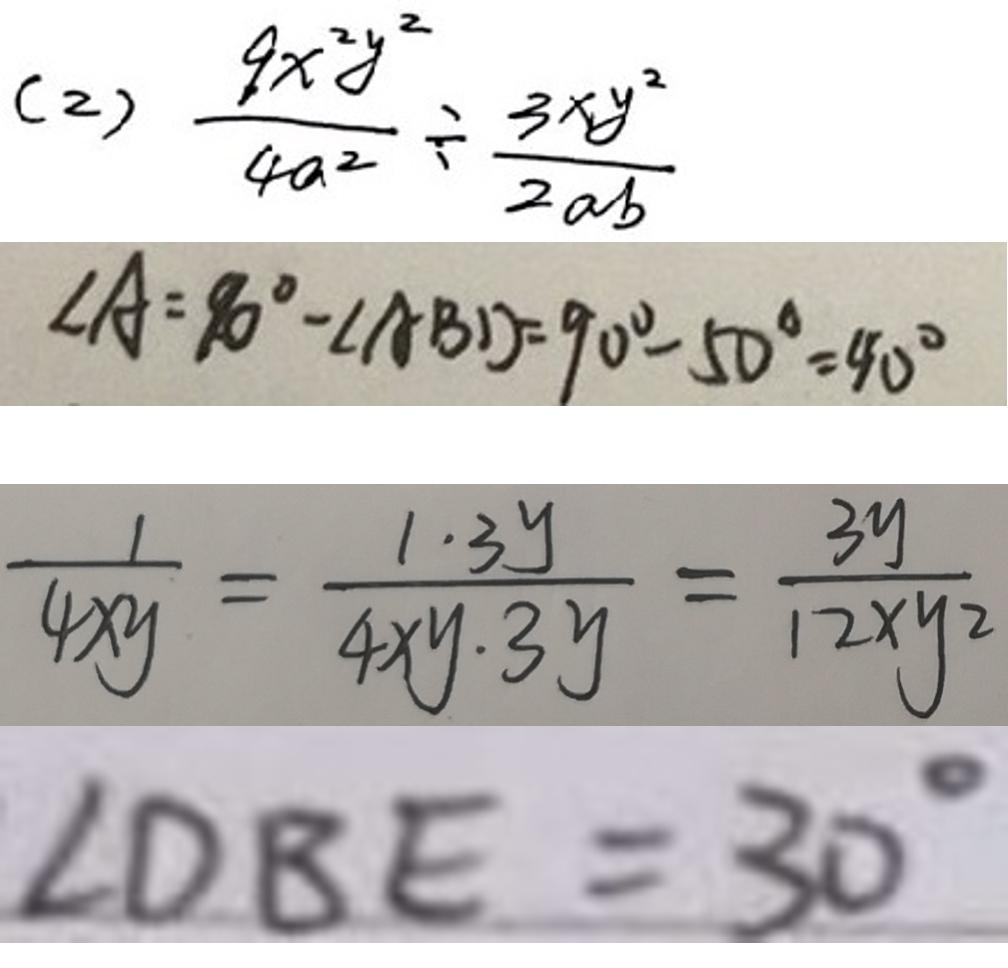<formula> <loc_0><loc_0><loc_500><loc_500>( 2 ) \frac { 9 x ^ { 2 } y ^ { 2 } } { 4 a ^ { 2 } } \div \frac { 3 x y ^ { 2 } } { 2 a b } 
 \angle A = 9 0 ^ { \circ } - \angle A B D = 9 0 ^ { \circ } - 5 0 ^ { \circ } = 9 0 ^ { c i r c } 
 \frac { 1 } { 4 x y } = \frac { 1 \cdot 3 y } { 4 x y \cdot 3 y } = \frac { 3 y } { 1 2 x y 2 } 
 \angle D B E = 3 0 ^ { \circ }</formula> 